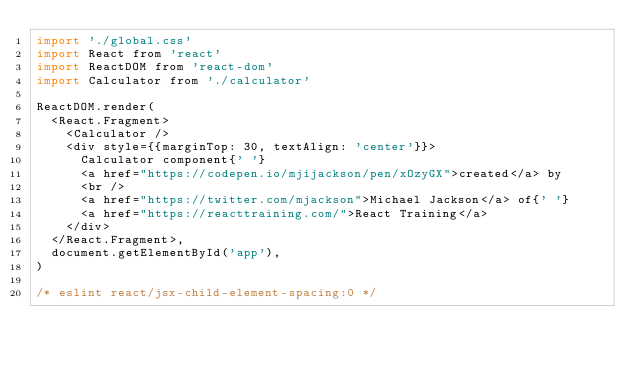<code> <loc_0><loc_0><loc_500><loc_500><_JavaScript_>import './global.css'
import React from 'react'
import ReactDOM from 'react-dom'
import Calculator from './calculator'

ReactDOM.render(
  <React.Fragment>
    <Calculator />
    <div style={{marginTop: 30, textAlign: 'center'}}>
      Calculator component{' '}
      <a href="https://codepen.io/mjijackson/pen/xOzyGX">created</a> by
      <br />
      <a href="https://twitter.com/mjackson">Michael Jackson</a> of{' '}
      <a href="https://reacttraining.com/">React Training</a>
    </div>
  </React.Fragment>,
  document.getElementById('app'),
)

/* eslint react/jsx-child-element-spacing:0 */
</code> 